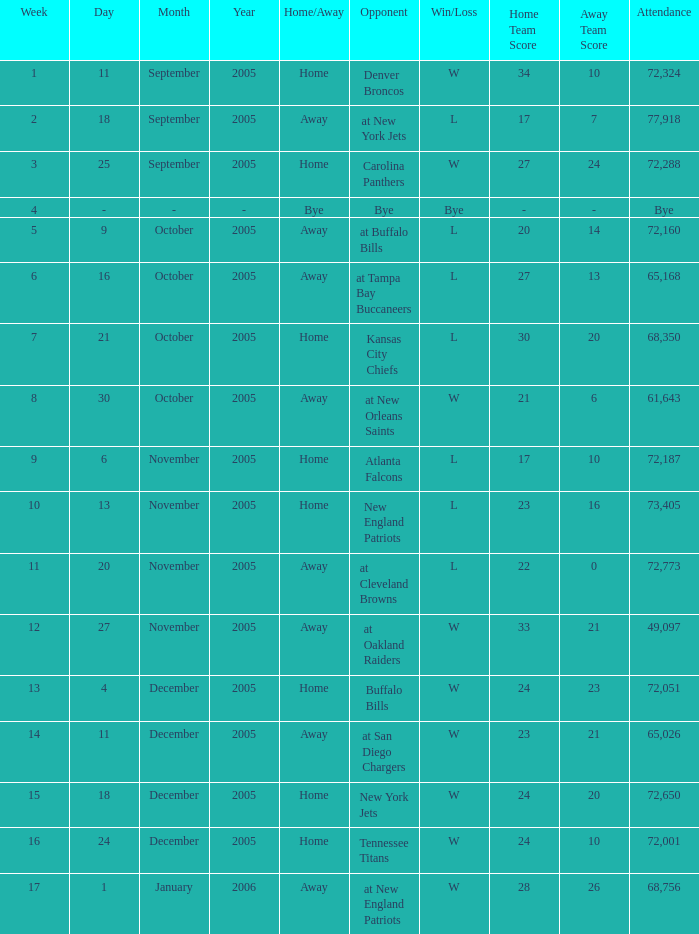In what Week was the Attendance 49,097? 12.0. Can you parse all the data within this table? {'header': ['Week', 'Day', 'Month', 'Year', 'Home/Away', 'Opponent', 'Win/Loss', 'Home Team Score', 'Away Team Score', 'Attendance'], 'rows': [['1', '11', 'September', '2005', 'Home', 'Denver Broncos', 'W', '34', '10', '72,324'], ['2', '18', 'September', '2005', 'Away', 'at New York Jets', 'L', '17', '7', '77,918'], ['3', '25', 'September', '2005', 'Home', 'Carolina Panthers', 'W', '27', '24', '72,288'], ['4', '-', '-', '-', 'Bye', 'Bye', 'Bye', '-', '-', 'Bye'], ['5', '9', 'October', '2005', 'Away', 'at Buffalo Bills', 'L', '20', '14', '72,160'], ['6', '16', 'October', '2005', 'Away', 'at Tampa Bay Buccaneers', 'L', '27', '13', '65,168'], ['7', '21', 'October', '2005', 'Home', 'Kansas City Chiefs', 'L', '30', '20', '68,350'], ['8', '30', 'October', '2005', 'Away', 'at New Orleans Saints', 'W', '21', '6', '61,643'], ['9', '6', 'November', '2005', 'Home', 'Atlanta Falcons', 'L', '17', '10', '72,187'], ['10', '13', 'November', '2005', 'Home', 'New England Patriots', 'L', '23', '16', '73,405'], ['11', '20', 'November', '2005', 'Away', 'at Cleveland Browns', 'L', '22', '0', '72,773'], ['12', '27', 'November', '2005', 'Away', 'at Oakland Raiders', 'W', '33', '21', '49,097'], ['13', '4', 'December', '2005', 'Home', 'Buffalo Bills', 'W', '24', '23', '72,051'], ['14', '11', 'December', '2005', 'Away', 'at San Diego Chargers', 'W', '23', '21', '65,026'], ['15', '18', 'December', '2005', 'Home', 'New York Jets', 'W', '24', '20', '72,650'], ['16', '24', 'December', '2005', 'Home', 'Tennessee Titans', 'W', '24', '10', '72,001'], ['17', '1', 'January', '2006', 'Away', 'at New England Patriots', 'W', '28', '26', '68,756']]} 